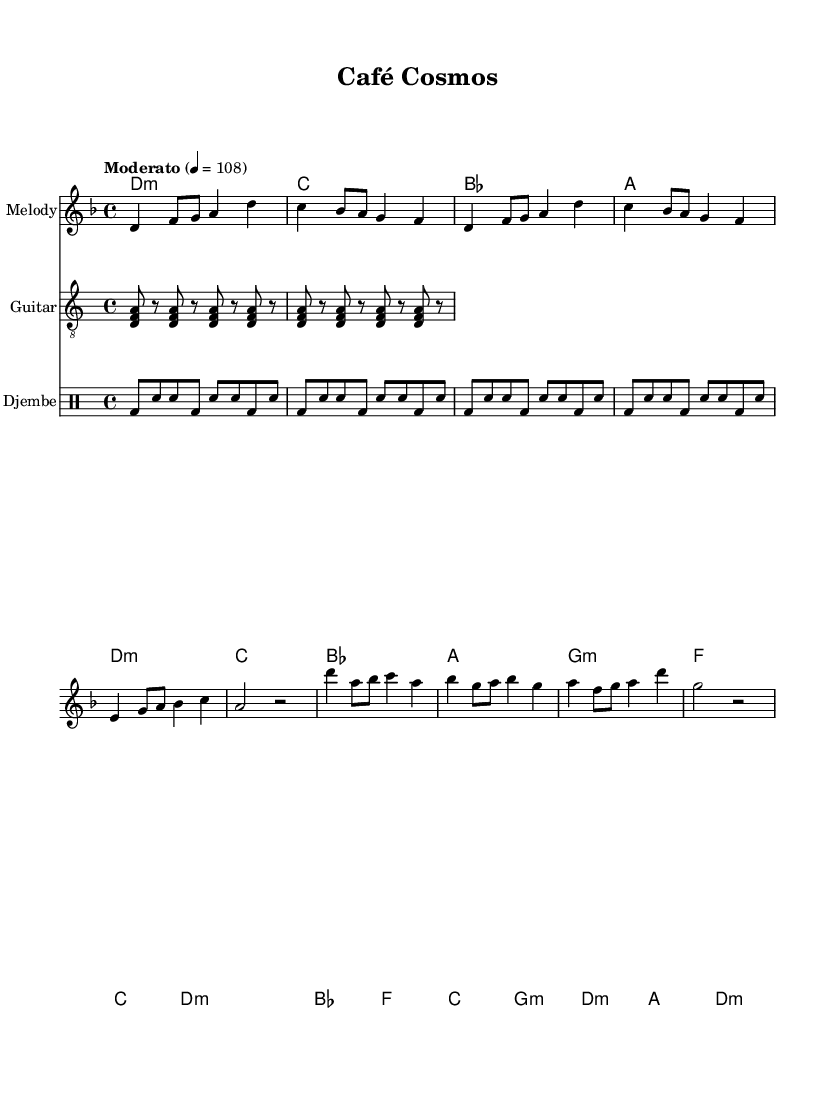What is the key signature of this music? The key signature is found at the beginning of the score, indicating D minor. D minor has one flat, B flat.
Answer: D minor What is the time signature of this music? The time signature is located next to the clef symbols at the beginning of the music and shows that it is in 4/4 time.
Answer: 4/4 What is the tempo marking for this piece? The tempo marking "Moderato" indicates a moderate speed of 108 beats per minute, which guides the performer's pace.
Answer: Moderato How many sections does the music have, and what are they? The music is structured in three main sections: Intro, Verse, and Chorus, as outlined in the score.
Answer: Intro, Verse, Chorus What instrument plays the djembe in this piece? The djembe is prominently indicated in the sheet music as a part of the percussion section, specifically labeled as the "Djembe" staff.
Answer: Djembe What type of harmony is used during the chorus? The harmony during the chorus includes various chords such as D minor, B flat, F, C, G minor, and back to D minor, combining traditional and contemporary elements.
Answer: D minor, B flat, F, C, G minor, D minor Which instruments are primarily involved in this fusion track? The music features a melody staff, a guitar staff, and a drum staff specifically for the djembe, indicating a blend of traditional and contemporary instruments.
Answer: Melody, Guitar, Djembe 